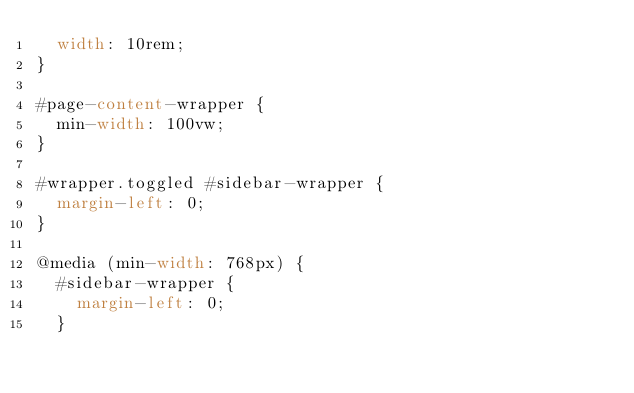Convert code to text. <code><loc_0><loc_0><loc_500><loc_500><_CSS_>  width: 10rem;
}

#page-content-wrapper {
  min-width: 100vw;
}

#wrapper.toggled #sidebar-wrapper {
  margin-left: 0;
}

@media (min-width: 768px) {
  #sidebar-wrapper {
    margin-left: 0;
  }
</code> 